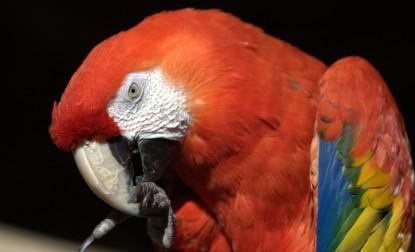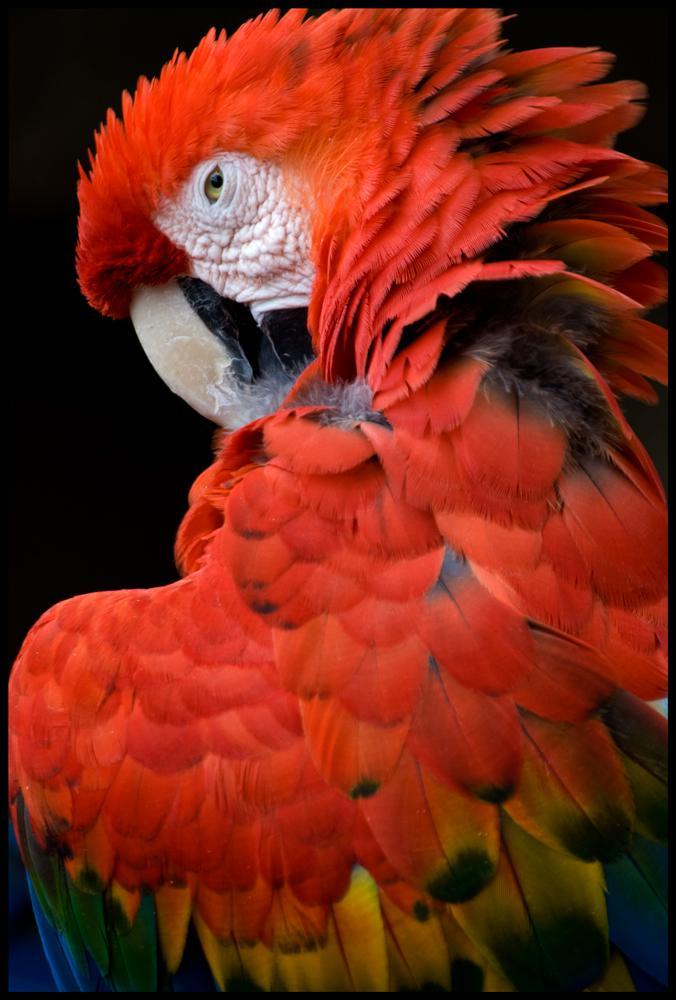The first image is the image on the left, the second image is the image on the right. Considering the images on both sides, is "The bird in the image on the right has its eyes closed." valid? Answer yes or no. No. The first image is the image on the left, the second image is the image on the right. Assess this claim about the two images: "Each image shows a red-headed bird with its face in profile and its eye shut.". Correct or not? Answer yes or no. No. 